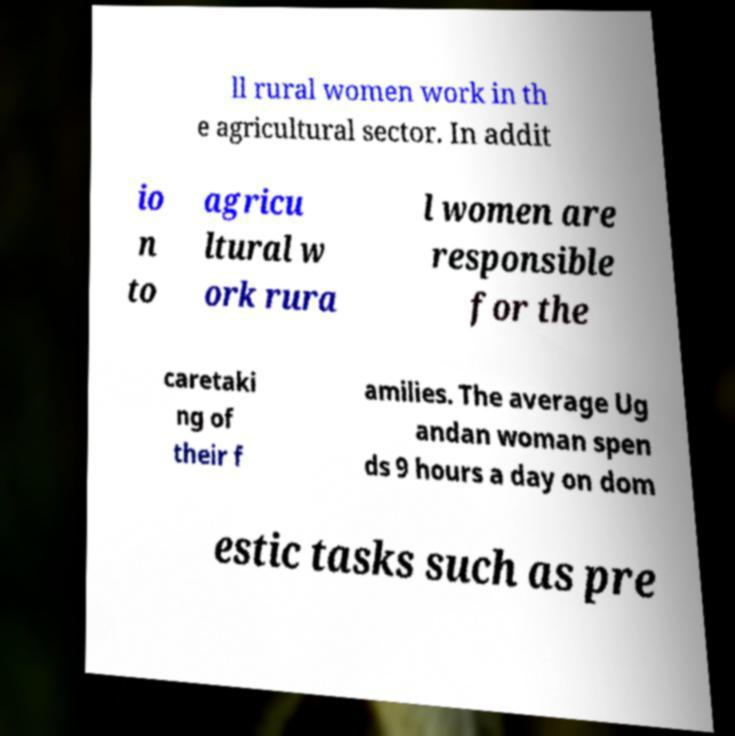What messages or text are displayed in this image? I need them in a readable, typed format. ll rural women work in th e agricultural sector. In addit io n to agricu ltural w ork rura l women are responsible for the caretaki ng of their f amilies. The average Ug andan woman spen ds 9 hours a day on dom estic tasks such as pre 